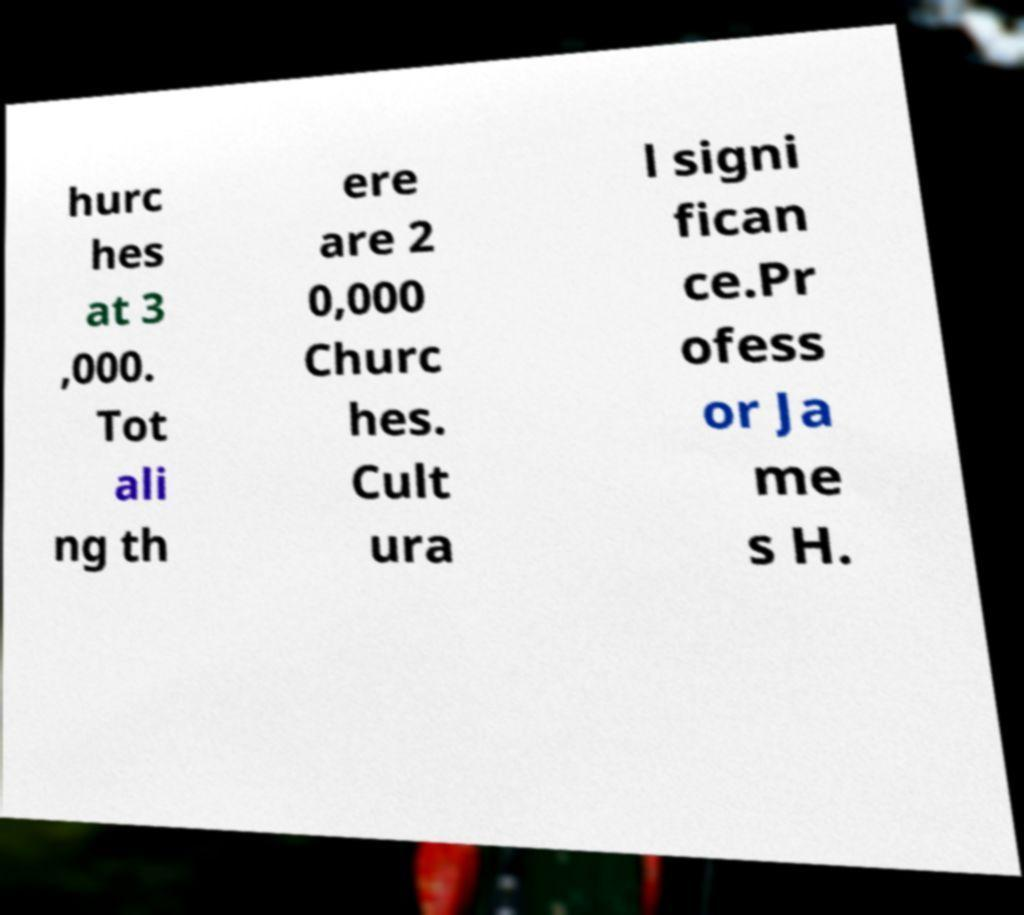What messages or text are displayed in this image? I need them in a readable, typed format. hurc hes at 3 ,000. Tot ali ng th ere are 2 0,000 Churc hes. Cult ura l signi fican ce.Pr ofess or Ja me s H. 